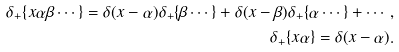Convert formula to latex. <formula><loc_0><loc_0><loc_500><loc_500>\delta _ { + } \{ x \alpha \beta \cdots \} = \delta ( x - \alpha ) \delta _ { + } \{ \beta \cdots \} + \delta ( x - \beta ) \delta _ { + } \{ \alpha \cdots \} + \cdots , \\ \delta _ { + } \{ x \alpha \} = \delta ( x - \alpha ) .</formula> 